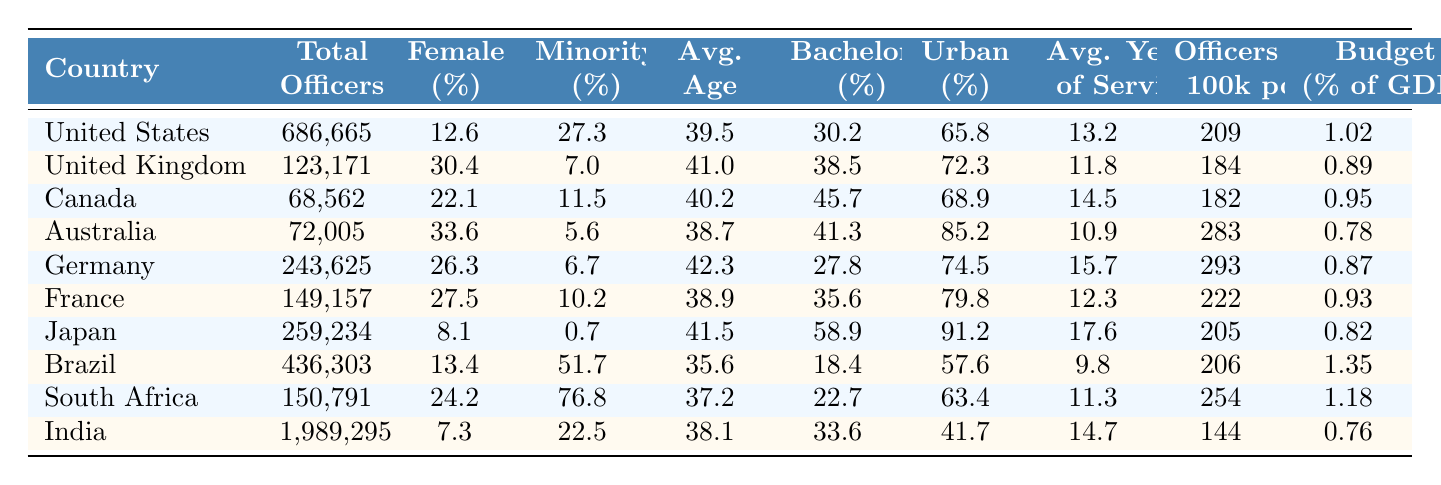What is the total number of law enforcement officers in India? The table lists the total number of officers in India as 1,989,295. This value can be found directly in the "total_officers" column next to India in the table.
Answer: 1,989,295 What is the female percentage of law enforcement personnel in the United Kingdom? The female percentage for the UK is shown as 30.4% in the "female_percentage" column associated with the United Kingdom.
Answer: 30.4 Which country has the highest average age among law enforcement officers? By comparing the values in the "average_age" column, Germany has the highest average age at 42.3.
Answer: Germany What is the difference in the total number of officers between Brazil and Canada? Brazil has 436,303 officers, and Canada has 68,562 officers. The difference is calculated as 436,303 - 68,562 = 367,741.
Answer: 367,741 Is the percentage of minority officers in Japan higher than in France? The minority percentage in Japan is 0.7%, and in France, it is 10.2%. Since 0.7% is not greater than 10.2%, the statement is false.
Answer: No What is the average percentage of law enforcement personnel with a bachelor's degree for the top three countries listed? The top three countries are the United States (30.2%), the United Kingdom (38.5%), and Canada (45.7%). To find the average, sum these values: 30.2 + 38.5 + 45.7 = 114.4, and then divide by 3, which gives 114.4 / 3 = 38.13%.
Answer: 38.13 Which country has the lowest budget percentage of GDP for law enforcement? By scanning the "budget_percentage_of_gdp" column, we see that India has the lowest budget percentage at 0.76%.
Answer: India What is the total number of officers per 100k population for South Africa and Brazil combined? For South Africa, it is 254 officers per 100k population, and for Brazil, it is 206. Adding these together gives 254 + 206 = 460.
Answer: 460 How many countries have more than 30% female representation in law enforcement? The countries with over 30% female representation are the United Kingdom (30.4%), Australia (33.6%), and France (27.5%), totaling three countries.
Answer: 3 Which country has the highest percentage of minority officers? Brazil has the highest percentage of minority officers at 51.7%, which can be directly seen in the "minority_percentage" column for Brazil.
Answer: Brazil 